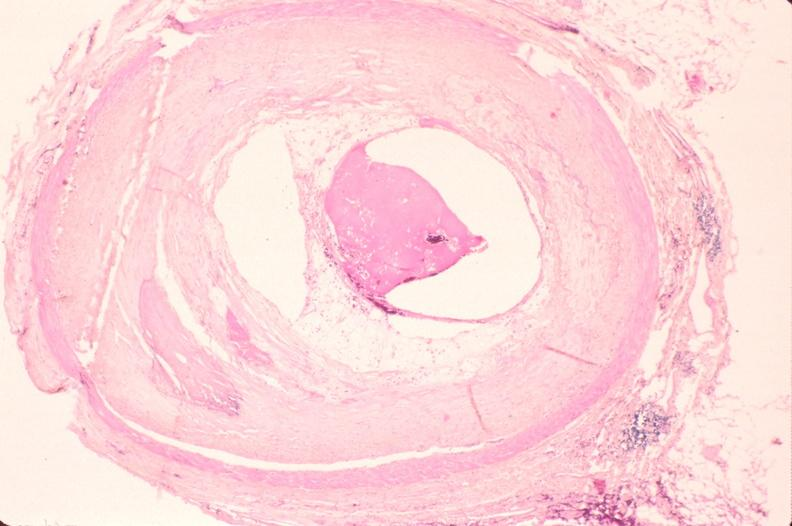what is atherosclerosis left?
Answer the question using a single word or phrase. Anterior descending coronary artery 